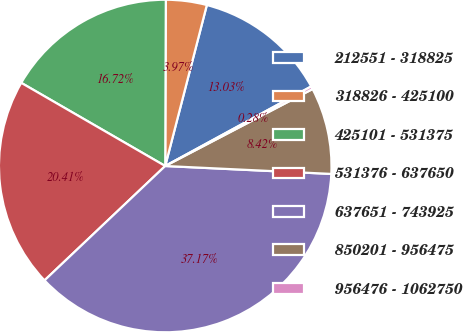Convert chart. <chart><loc_0><loc_0><loc_500><loc_500><pie_chart><fcel>212551 - 318825<fcel>318826 - 425100<fcel>425101 - 531375<fcel>531376 - 637650<fcel>637651 - 743925<fcel>850201 - 956475<fcel>956476 - 1062750<nl><fcel>13.03%<fcel>3.97%<fcel>16.72%<fcel>20.41%<fcel>37.17%<fcel>8.42%<fcel>0.28%<nl></chart> 